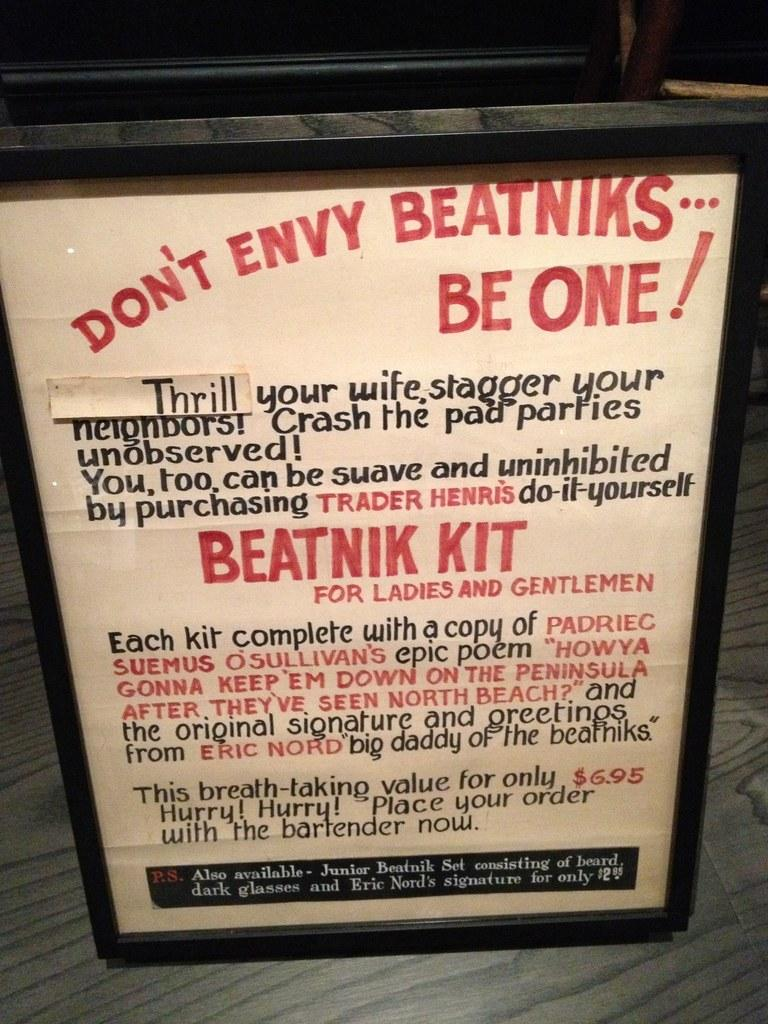<image>
Render a clear and concise summary of the photo. A sign that starts "Don't envy the beatniks...be one!" 